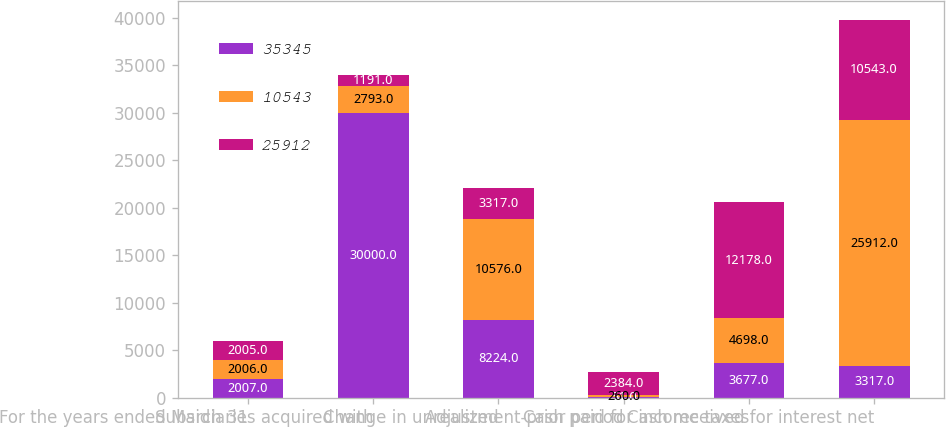Convert chart to OTSL. <chart><loc_0><loc_0><loc_500><loc_500><stacked_bar_chart><ecel><fcel>For the years ended March 31<fcel>Subsidiaries acquired with<fcel>Change in unrealized<fcel>Adjustment-prior period<fcel>Cash paid for income taxes<fcel>Cash received for interest net<nl><fcel>35345<fcel>2007<fcel>30000<fcel>8224<fcel>51<fcel>3677<fcel>3317<nl><fcel>10543<fcel>2006<fcel>2793<fcel>10576<fcel>260<fcel>4698<fcel>25912<nl><fcel>25912<fcel>2005<fcel>1191<fcel>3317<fcel>2384<fcel>12178<fcel>10543<nl></chart> 